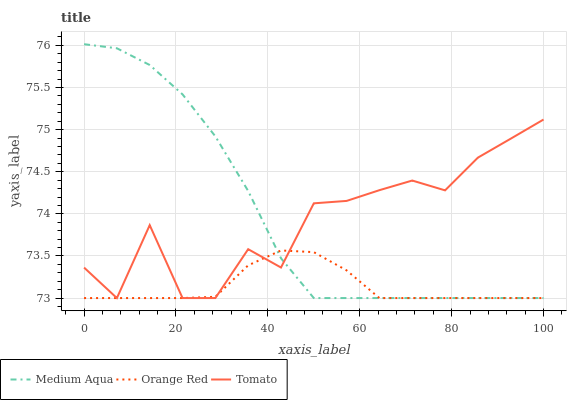Does Orange Red have the minimum area under the curve?
Answer yes or no. Yes. Does Medium Aqua have the maximum area under the curve?
Answer yes or no. Yes. Does Medium Aqua have the minimum area under the curve?
Answer yes or no. No. Does Orange Red have the maximum area under the curve?
Answer yes or no. No. Is Orange Red the smoothest?
Answer yes or no. Yes. Is Tomato the roughest?
Answer yes or no. Yes. Is Medium Aqua the smoothest?
Answer yes or no. No. Is Medium Aqua the roughest?
Answer yes or no. No. Does Medium Aqua have the highest value?
Answer yes or no. Yes. Does Orange Red have the highest value?
Answer yes or no. No. Does Tomato intersect Orange Red?
Answer yes or no. Yes. Is Tomato less than Orange Red?
Answer yes or no. No. Is Tomato greater than Orange Red?
Answer yes or no. No. 